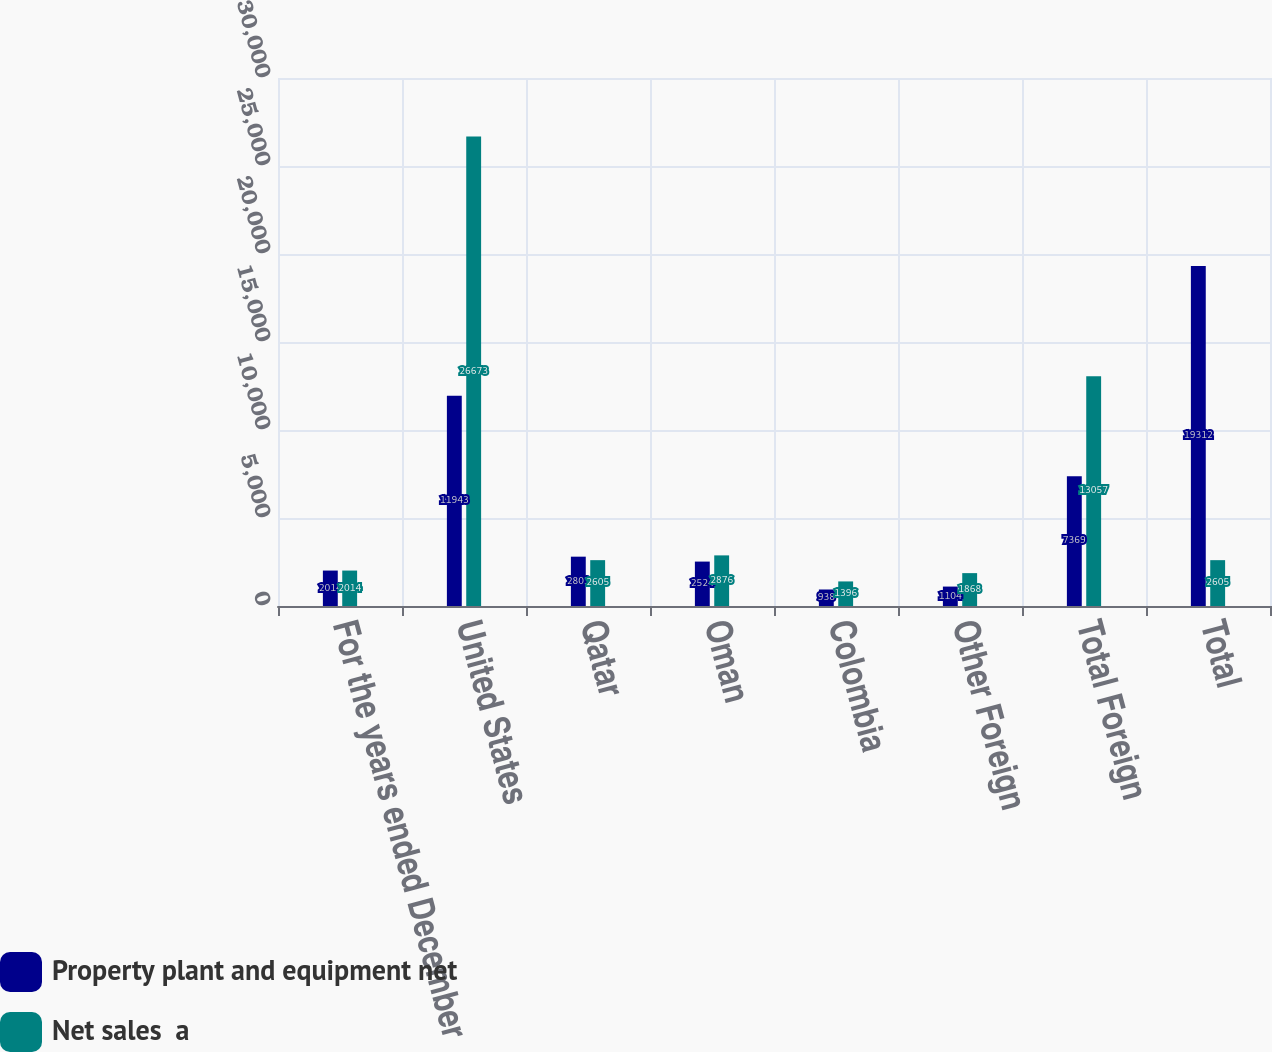Convert chart to OTSL. <chart><loc_0><loc_0><loc_500><loc_500><stacked_bar_chart><ecel><fcel>For the years ended December<fcel>United States<fcel>Qatar<fcel>Oman<fcel>Colombia<fcel>Other Foreign<fcel>Total Foreign<fcel>Total<nl><fcel>Property plant and equipment net<fcel>2014<fcel>11943<fcel>2803<fcel>2524<fcel>938<fcel>1104<fcel>7369<fcel>19312<nl><fcel>Net sales  a<fcel>2014<fcel>26673<fcel>2605<fcel>2876<fcel>1396<fcel>1868<fcel>13057<fcel>2605<nl></chart> 